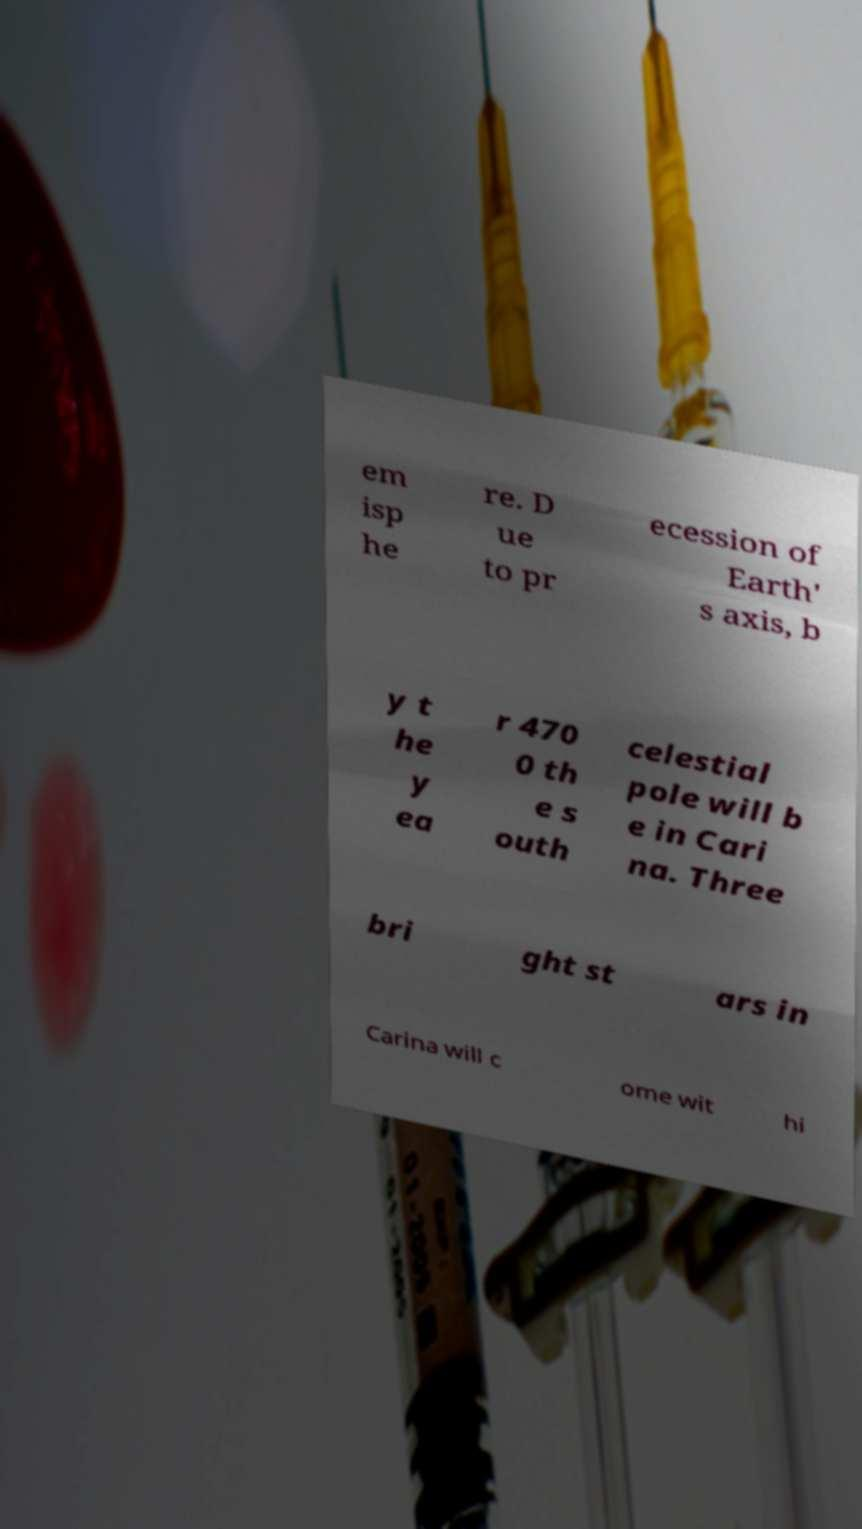What messages or text are displayed in this image? I need them in a readable, typed format. em isp he re. D ue to pr ecession of Earth' s axis, b y t he y ea r 470 0 th e s outh celestial pole will b e in Cari na. Three bri ght st ars in Carina will c ome wit hi 